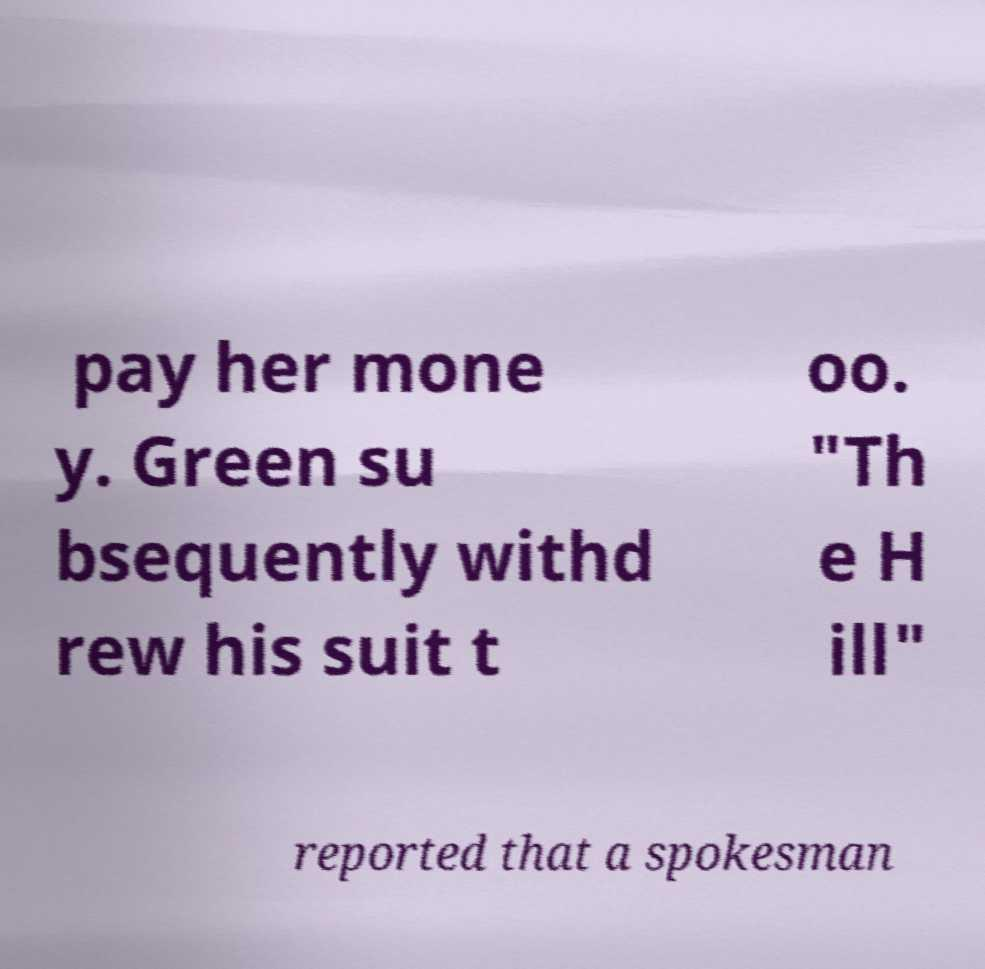Please identify and transcribe the text found in this image. pay her mone y. Green su bsequently withd rew his suit t oo. "Th e H ill" reported that a spokesman 